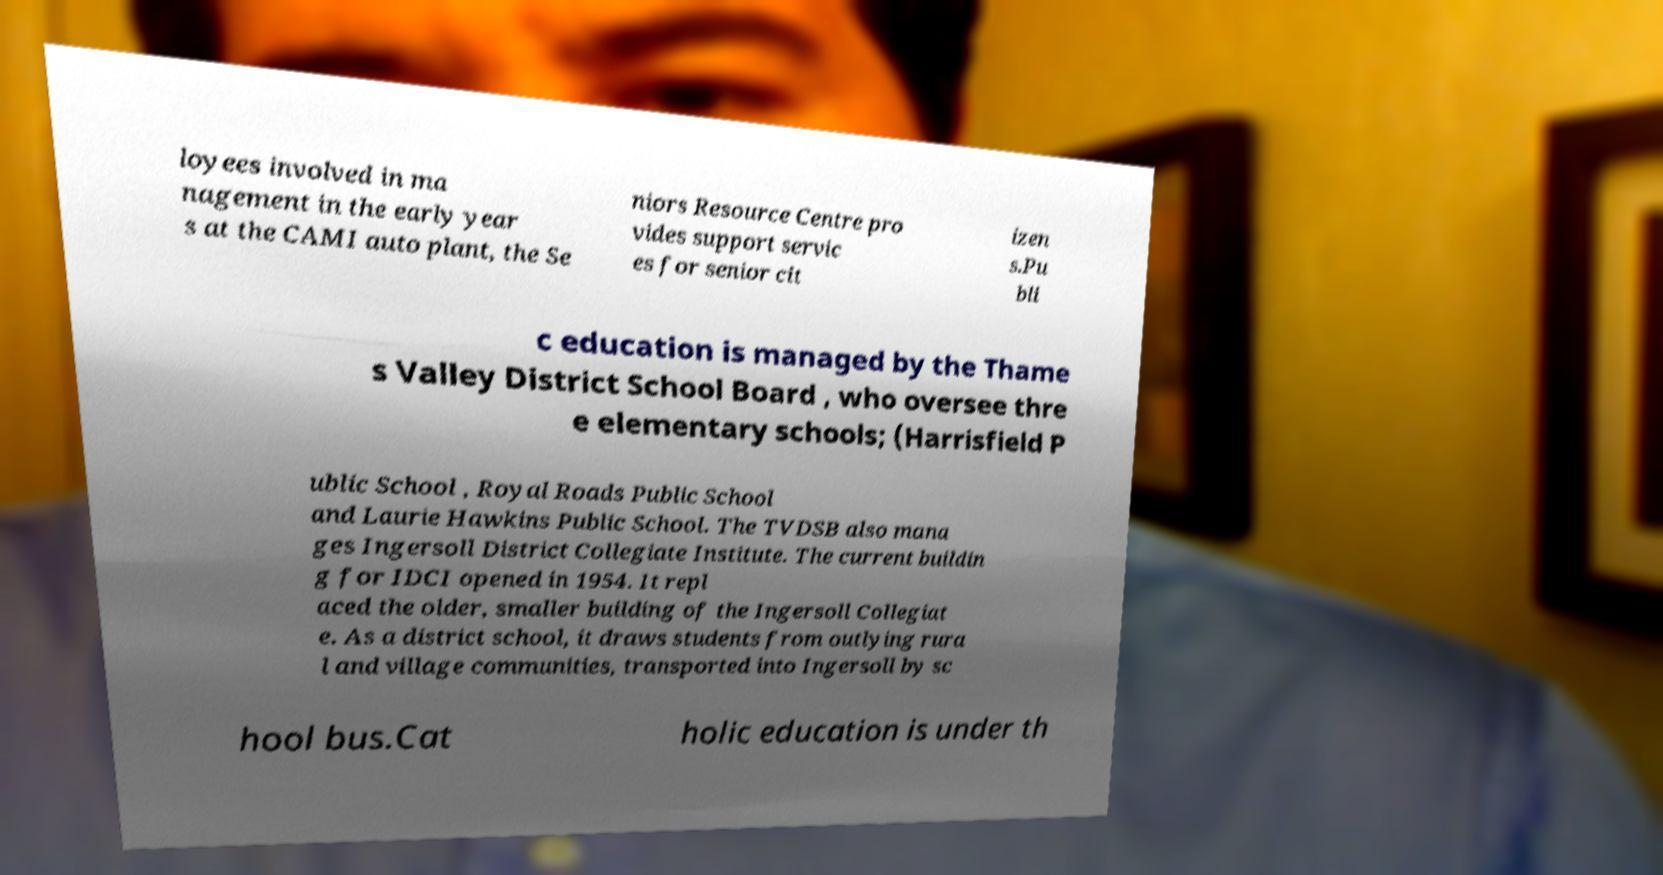For documentation purposes, I need the text within this image transcribed. Could you provide that? loyees involved in ma nagement in the early year s at the CAMI auto plant, the Se niors Resource Centre pro vides support servic es for senior cit izen s.Pu bli c education is managed by the Thame s Valley District School Board , who oversee thre e elementary schools; (Harrisfield P ublic School , Royal Roads Public School and Laurie Hawkins Public School. The TVDSB also mana ges Ingersoll District Collegiate Institute. The current buildin g for IDCI opened in 1954. It repl aced the older, smaller building of the Ingersoll Collegiat e. As a district school, it draws students from outlying rura l and village communities, transported into Ingersoll by sc hool bus.Cat holic education is under th 